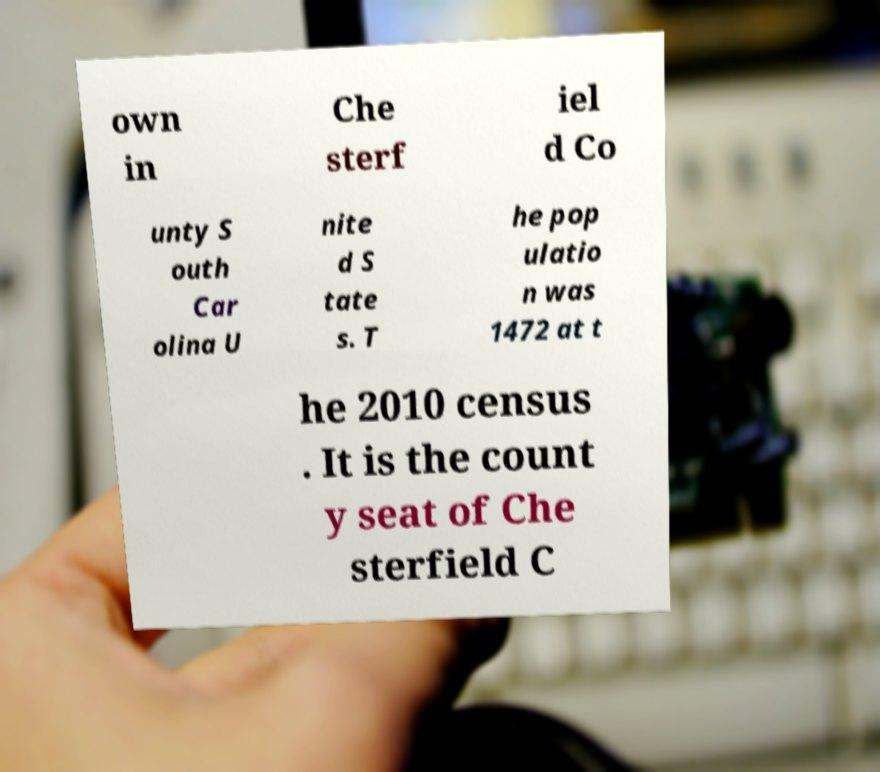There's text embedded in this image that I need extracted. Can you transcribe it verbatim? own in Che sterf iel d Co unty S outh Car olina U nite d S tate s. T he pop ulatio n was 1472 at t he 2010 census . It is the count y seat of Che sterfield C 